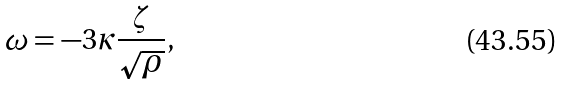Convert formula to latex. <formula><loc_0><loc_0><loc_500><loc_500>\omega = - 3 \kappa \frac { \zeta } { \sqrt { \rho } } ,</formula> 